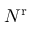<formula> <loc_0><loc_0><loc_500><loc_500>N ^ { r }</formula> 